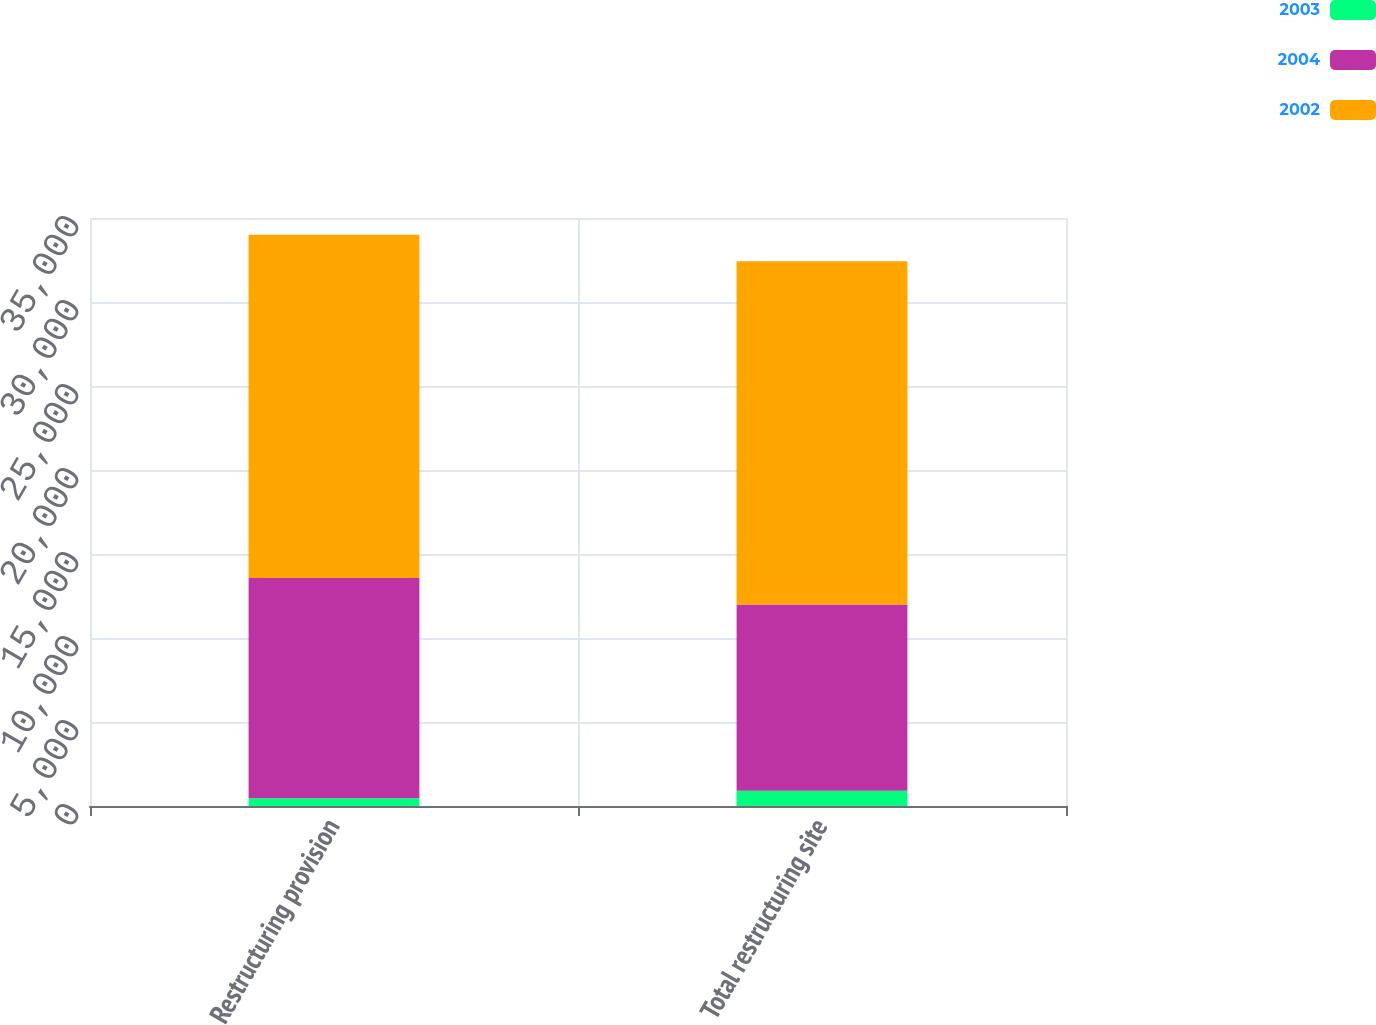Convert chart. <chart><loc_0><loc_0><loc_500><loc_500><stacked_bar_chart><ecel><fcel>Restructuring provision<fcel>Total restructuring site<nl><fcel>2003<fcel>465<fcel>907<nl><fcel>2004<fcel>13113<fcel>11089<nl><fcel>2002<fcel>20428<fcel>20428<nl></chart> 